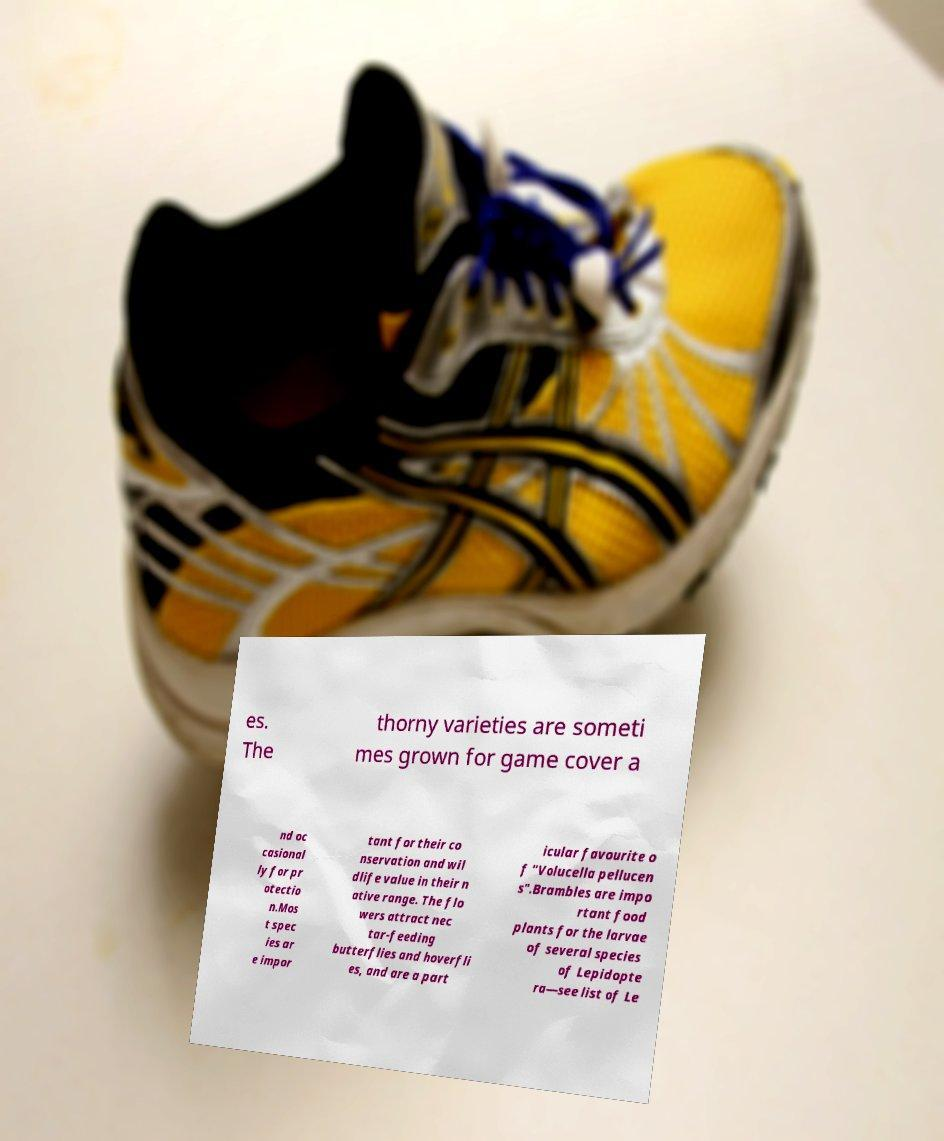Please read and relay the text visible in this image. What does it say? es. The thorny varieties are someti mes grown for game cover a nd oc casional ly for pr otectio n.Mos t spec ies ar e impor tant for their co nservation and wil dlife value in their n ative range. The flo wers attract nec tar-feeding butterflies and hoverfli es, and are a part icular favourite o f "Volucella pellucen s".Brambles are impo rtant food plants for the larvae of several species of Lepidopte ra—see list of Le 